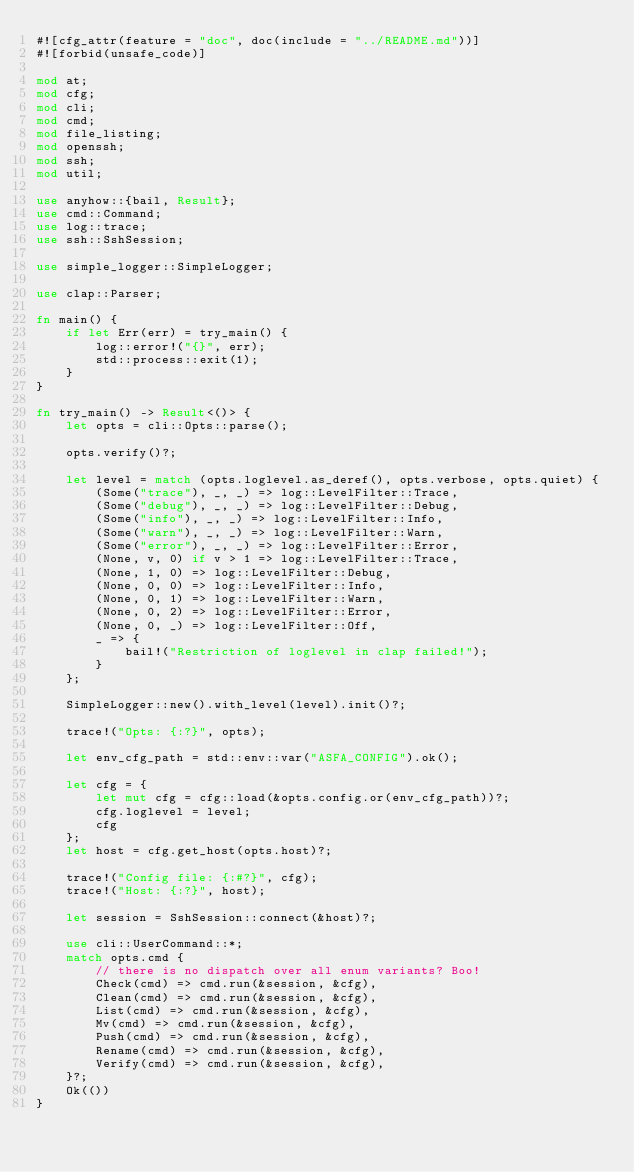<code> <loc_0><loc_0><loc_500><loc_500><_Rust_>#![cfg_attr(feature = "doc", doc(include = "../README.md"))]
#![forbid(unsafe_code)]

mod at;
mod cfg;
mod cli;
mod cmd;
mod file_listing;
mod openssh;
mod ssh;
mod util;

use anyhow::{bail, Result};
use cmd::Command;
use log::trace;
use ssh::SshSession;

use simple_logger::SimpleLogger;

use clap::Parser;

fn main() {
    if let Err(err) = try_main() {
        log::error!("{}", err);
        std::process::exit(1);
    }
}

fn try_main() -> Result<()> {
    let opts = cli::Opts::parse();

    opts.verify()?;

    let level = match (opts.loglevel.as_deref(), opts.verbose, opts.quiet) {
        (Some("trace"), _, _) => log::LevelFilter::Trace,
        (Some("debug"), _, _) => log::LevelFilter::Debug,
        (Some("info"), _, _) => log::LevelFilter::Info,
        (Some("warn"), _, _) => log::LevelFilter::Warn,
        (Some("error"), _, _) => log::LevelFilter::Error,
        (None, v, 0) if v > 1 => log::LevelFilter::Trace,
        (None, 1, 0) => log::LevelFilter::Debug,
        (None, 0, 0) => log::LevelFilter::Info,
        (None, 0, 1) => log::LevelFilter::Warn,
        (None, 0, 2) => log::LevelFilter::Error,
        (None, 0, _) => log::LevelFilter::Off,
        _ => {
            bail!("Restriction of loglevel in clap failed!");
        }
    };

    SimpleLogger::new().with_level(level).init()?;

    trace!("Opts: {:?}", opts);

    let env_cfg_path = std::env::var("ASFA_CONFIG").ok();

    let cfg = {
        let mut cfg = cfg::load(&opts.config.or(env_cfg_path))?;
        cfg.loglevel = level;
        cfg
    };
    let host = cfg.get_host(opts.host)?;

    trace!("Config file: {:#?}", cfg);
    trace!("Host: {:?}", host);

    let session = SshSession::connect(&host)?;

    use cli::UserCommand::*;
    match opts.cmd {
        // there is no dispatch over all enum variants? Boo!
        Check(cmd) => cmd.run(&session, &cfg),
        Clean(cmd) => cmd.run(&session, &cfg),
        List(cmd) => cmd.run(&session, &cfg),
        Mv(cmd) => cmd.run(&session, &cfg),
        Push(cmd) => cmd.run(&session, &cfg),
        Rename(cmd) => cmd.run(&session, &cfg),
        Verify(cmd) => cmd.run(&session, &cfg),
    }?;
    Ok(())
}
</code> 